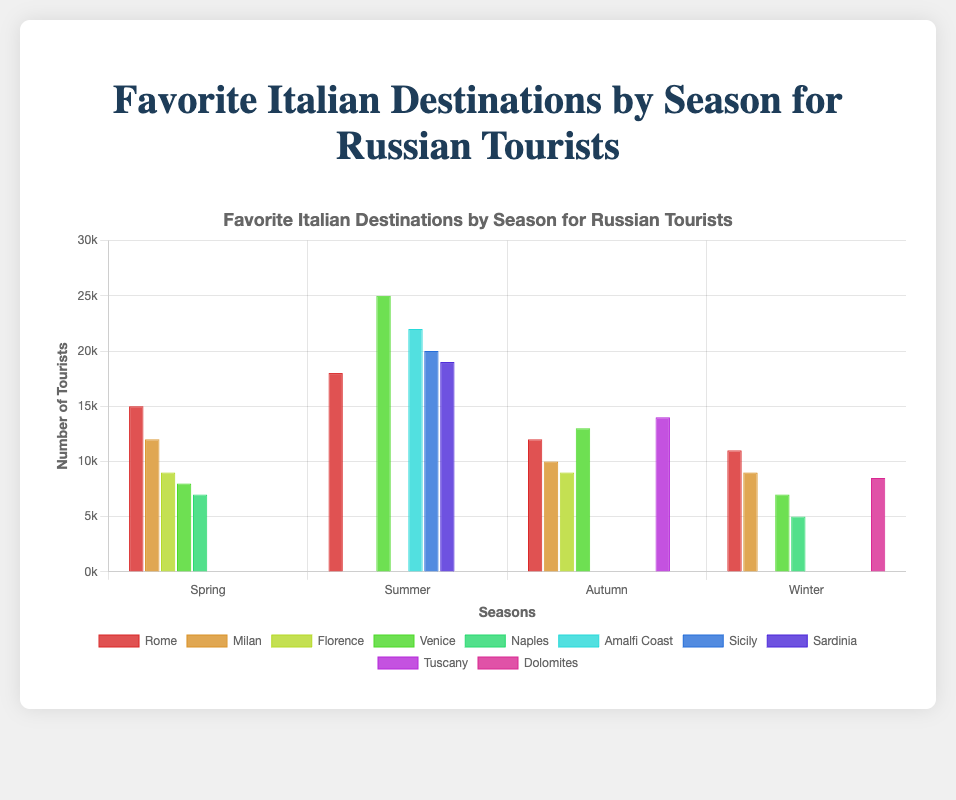Which destination had the highest number of tourists in Summer? The highest bar in the Summer group corresponds to Venice, indicating it received the most tourists.
Answer: Venice Which season had the highest total number of tourists visiting Venice? Add the numbers of tourists visiting Venice in all seasons. Venice has 8000 in Spring, 25000 in Summer, 13000 in Autumn, and 7000 in Winter. The highest number is 25000 in Summer.
Answer: Summer What is the difference in tourist numbers between Spring and Autumn for Rome? Rome had 15000 tourists in Spring and 12000 in Autumn. Subtracting these numbers gives the difference: 15000 - 12000 = 3000.
Answer: 3000 How many more tourists visited Milan in Spring compared to Winter? Milan had 12000 tourists in Spring and 9000 in Winter. The difference is 12000 - 9000 = 3000.
Answer: 3000 Which is the least popular destination in Winter, and how many tourists visited it? The shortest bar in the Winter group is for Naples, which had 5000 tourists.
Answer: Naples, 5000 In which season did Milan receive the highest number of tourists? By comparing the bars for Milan across all seasons, the highest bar is in Spring with 12000 tourists.
Answer: Spring What is the average number of tourists visiting Rome across all seasons? Sum up the tourists for Rome in each season (15000 Spring, 18000 Summer, 12000 Autumn, 11000 Winter) and divide by 4. (15000+18000+12000+11000)/4 = 14000.
Answer: 14000 Is the number of tourists visiting Florence higher in Spring or Autumn? The bar for Florence in Spring is 9000 and in Autumn is also 9000, so it is the same across both seasons.
Answer: Equal Which season had the highest overall number of tourists among all given destinations? Sum the number of tourists for all destinations in each season. The totals are: 
Spring: 15000 + 12000 + 9000 + 8000 + 7000 = 51000
Summer: 25000 + 22000 + 20000 + 19000 + 18000 = 104000
Autumn: 14000 + 13000 + 12000 + 10000 + 9000 = 58000
Winter: 11000 + 9000 + 8500 + 7000 + 5000 = 40500
The highest total is in Summer with 104000 tourists.
Answer: Summer Which destination received tourists in all seasons, and what is the total number of tourists that visited this destination? The destinations appearing in all seasons are Rome and Milan. Summing the tourists for Rome: 15000 (Spring) + 18000 (Summer) + 12000 (Autumn) + 11000 (Winter) = 56000, and for Milan: 12000 (Spring) + 10000 (Autumn) + 9000 (Winter) = 31000. Therefore, the destination visited in all seasons with tourist counts is Rome with 56000 tourists.
Answer: Rome, 56000 